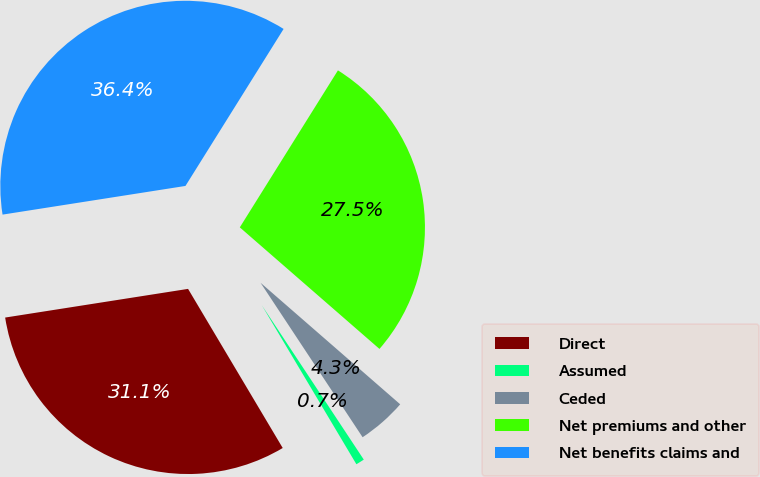<chart> <loc_0><loc_0><loc_500><loc_500><pie_chart><fcel>Direct<fcel>Assumed<fcel>Ceded<fcel>Net premiums and other<fcel>Net benefits claims and<nl><fcel>31.07%<fcel>0.75%<fcel>4.31%<fcel>27.51%<fcel>36.37%<nl></chart> 